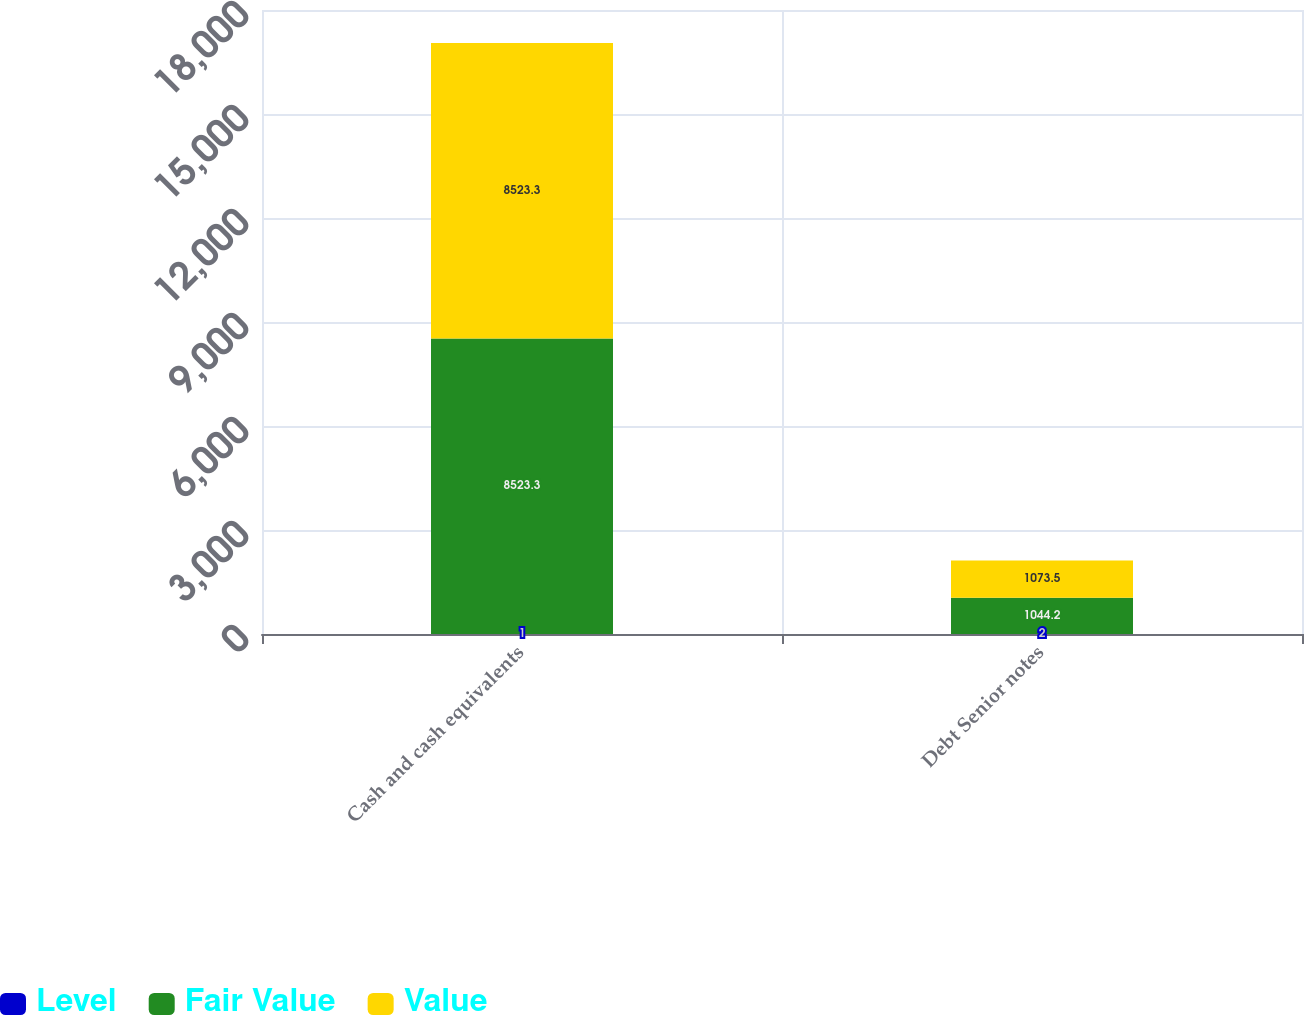<chart> <loc_0><loc_0><loc_500><loc_500><stacked_bar_chart><ecel><fcel>Cash and cash equivalents<fcel>Debt Senior notes<nl><fcel>Level<fcel>1<fcel>2<nl><fcel>Fair Value<fcel>8523.3<fcel>1044.2<nl><fcel>Value<fcel>8523.3<fcel>1073.5<nl></chart> 